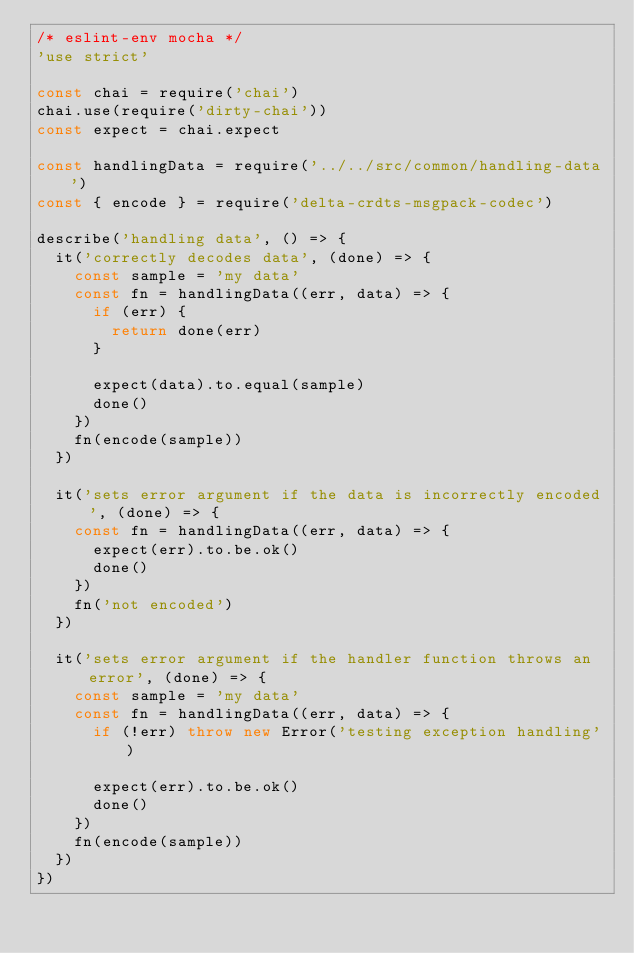Convert code to text. <code><loc_0><loc_0><loc_500><loc_500><_JavaScript_>/* eslint-env mocha */
'use strict'

const chai = require('chai')
chai.use(require('dirty-chai'))
const expect = chai.expect

const handlingData = require('../../src/common/handling-data')
const { encode } = require('delta-crdts-msgpack-codec')

describe('handling data', () => {
  it('correctly decodes data', (done) => {
    const sample = 'my data'
    const fn = handlingData((err, data) => {
      if (err) {
        return done(err)
      }

      expect(data).to.equal(sample)
      done()
    })
    fn(encode(sample))
  })

  it('sets error argument if the data is incorrectly encoded', (done) => {
    const fn = handlingData((err, data) => {
      expect(err).to.be.ok()
      done()
    })
    fn('not encoded')
  })

  it('sets error argument if the handler function throws an error', (done) => {
    const sample = 'my data'
    const fn = handlingData((err, data) => {
      if (!err) throw new Error('testing exception handling')

      expect(err).to.be.ok()
      done()
    })
    fn(encode(sample))
  })
})
</code> 